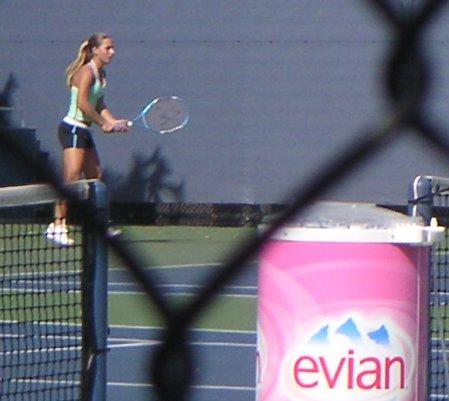Question: what is written on the object next to the net?
Choices:
A. Beats by dre.
B. Score 0-0.
C. Evian.
D. The rules.
Answer with the letter. Answer: C Question: what is the tennis player holding in her hand?
Choices:
A. A tennis ball.
B. A water bottle.
C. A tennis racket.
D. Her husbands hand.
Answer with the letter. Answer: C Question: where was this taken?
Choices:
A. On a tennis court.
B. On the bed.
C. Next to the red barn.
D. At the effile tower.
Answer with the letter. Answer: A Question: why is the woman holding a tennis racket?
Choices:
A. Shes going to practice.
B. To throw it away.
C. She is playing tennis.
D. To put it in her car.
Answer with the letter. Answer: C Question: who is wearing a light green tank top?
Choices:
A. I am.
B. The woman holding a racket.
C. The wallmart worker.
D. My aunt Carrol.
Answer with the letter. Answer: B Question: when was this taken?
Choices:
A. During the day.
B. During the night.
C. At dawn.
D. At dusk.
Answer with the letter. Answer: A 